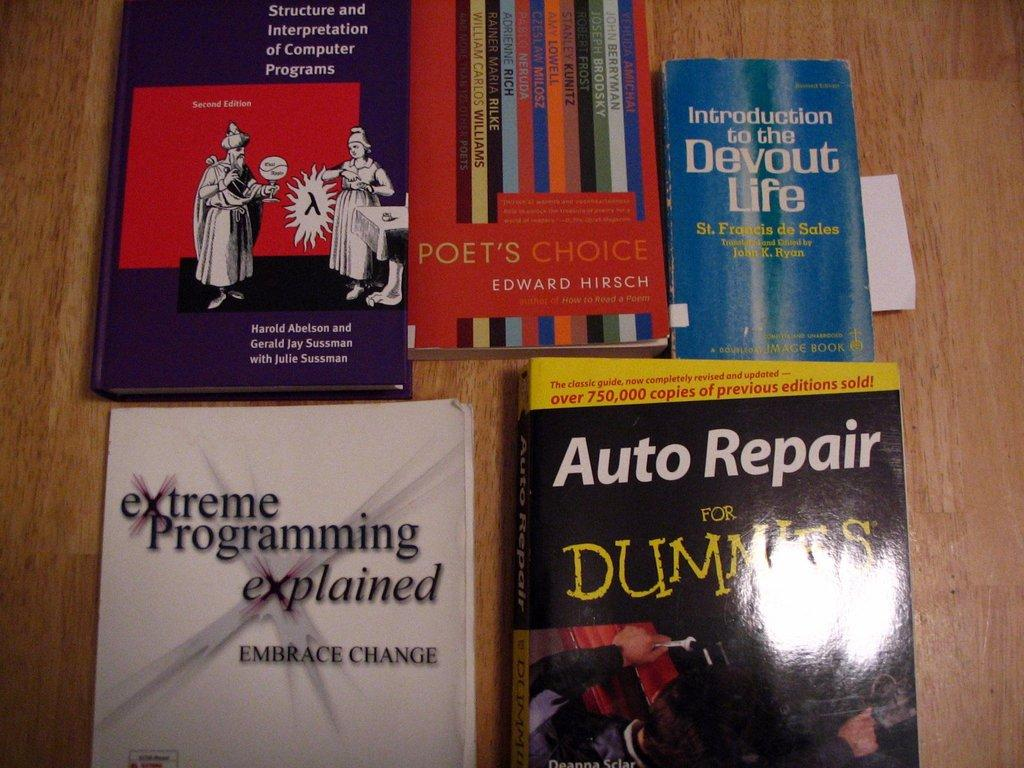<image>
Give a short and clear explanation of the subsequent image. Several books laid out next to each other, including a copy of "Auto Repair For Dummies." 